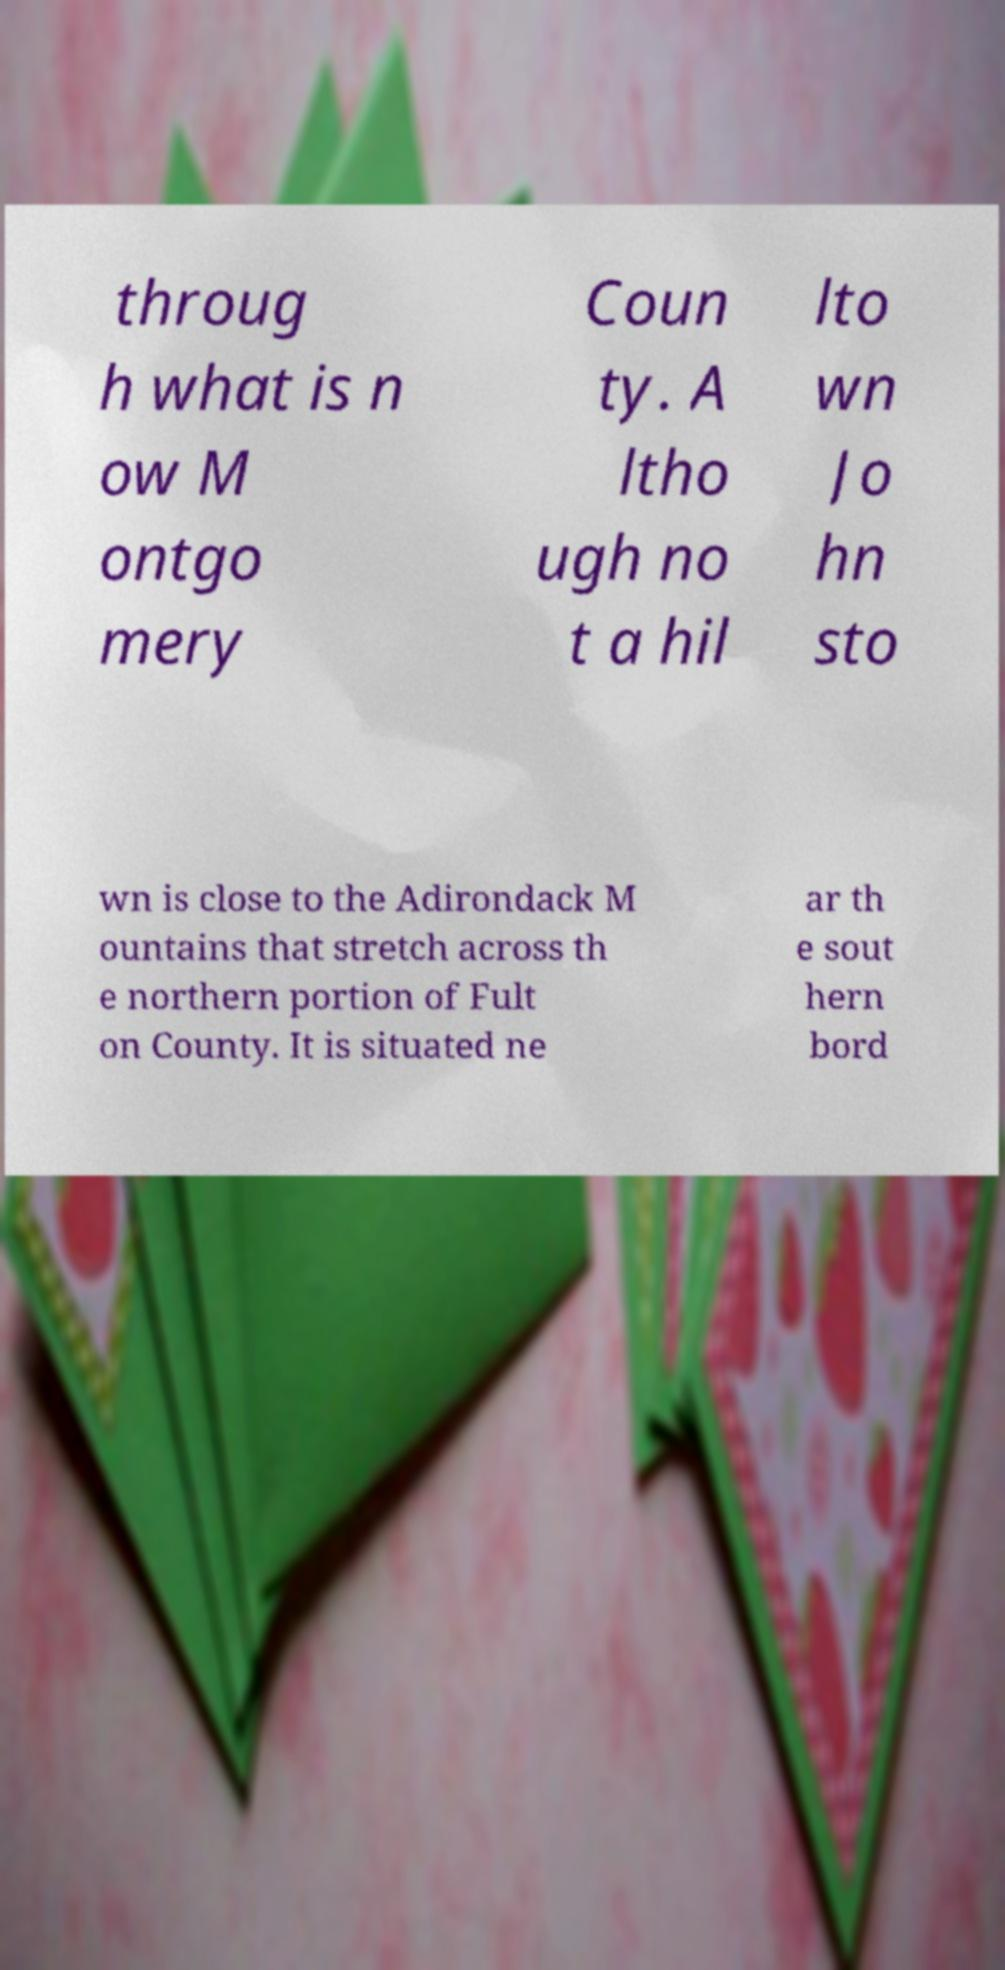Can you read and provide the text displayed in the image?This photo seems to have some interesting text. Can you extract and type it out for me? throug h what is n ow M ontgo mery Coun ty. A ltho ugh no t a hil lto wn Jo hn sto wn is close to the Adirondack M ountains that stretch across th e northern portion of Fult on County. It is situated ne ar th e sout hern bord 